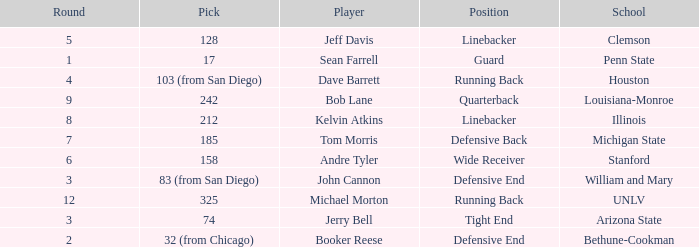What pick did Clemson choose? 128.0. 